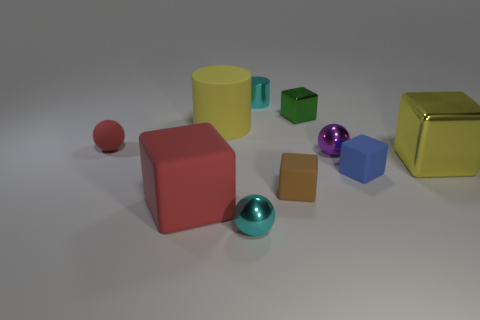What material is the small sphere that is the same color as the shiny cylinder?
Ensure brevity in your answer.  Metal. The large metallic thing that is the same shape as the large red matte thing is what color?
Offer a very short reply. Yellow. There is a ball that is the same material as the brown thing; what is its color?
Your answer should be very brief. Red. Are there an equal number of small cyan shiny spheres on the right side of the small green block and red rubber things?
Give a very brief answer. No. There is a red object that is in front of the purple metal object; does it have the same size as the yellow block?
Make the answer very short. Yes. What color is the rubber cylinder that is the same size as the yellow shiny thing?
Make the answer very short. Yellow. Is there a cyan shiny ball to the left of the small cyan metallic thing that is in front of the large cube on the right side of the green cube?
Keep it short and to the point. No. What material is the cyan thing in front of the purple metal ball?
Your answer should be very brief. Metal. Does the yellow matte thing have the same shape as the small cyan object that is in front of the small red object?
Offer a very short reply. No. Are there an equal number of red objects that are behind the large metallic object and large metal blocks that are behind the red rubber sphere?
Make the answer very short. No. 